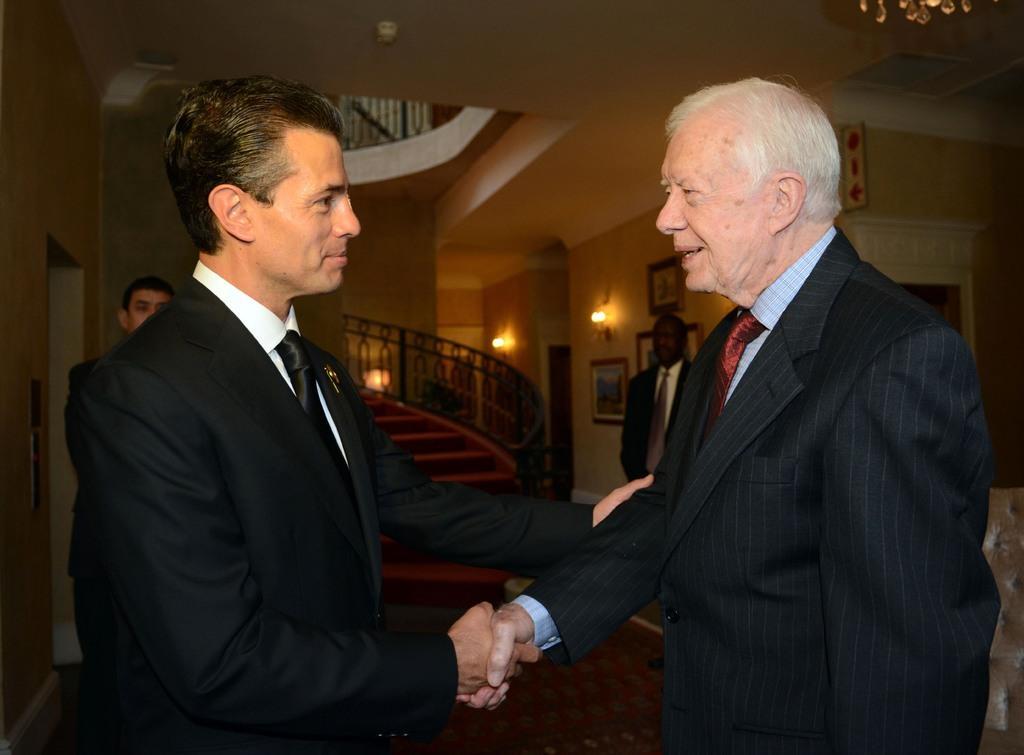Can you describe this image briefly? In this picture we can see four men standing on the floor where two are shaking their hands and smiling and in the background we can see steps, lights, frames on the wall. 